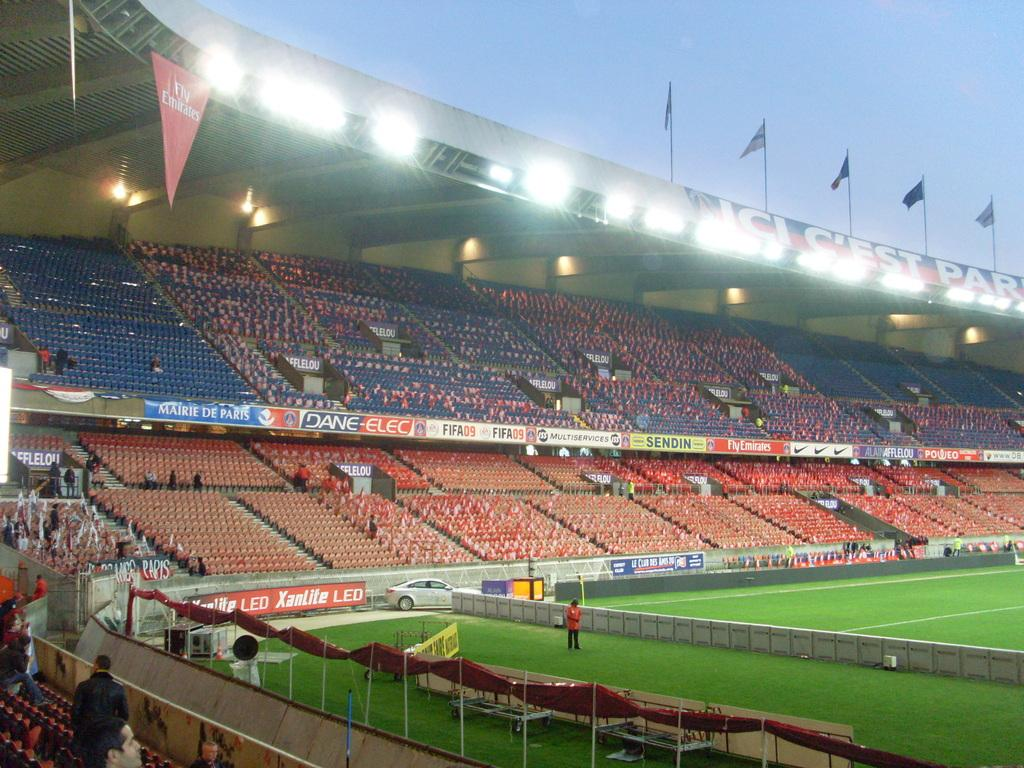What objects can be seen in the image that are used for support or display? In the image, there are poles and boards that can be used for support or display. What items in the image are used for signaling or identification? Flags are present in the image for signaling or identification. What objects in the image provide illumination? There are lights in the image that provide illumination. What objects in the image are used for seating? Chairs are present in the image for seating. What can be observed in the image that indicates a gathering of people? There is a crowd in the image, suggesting a gathering of people. What is on the ground in the image? There is a car on the ground in the image. What is visible in the background of the image? Sky is visible in the background of the image. What type of cushion is being used to clean the jewel in the image? There is no cushion or jewel present in the image. How does the dirt in the image affect the visibility of the objects? There is no dirt present in the image, so it does not affect the visibility of the objects. 